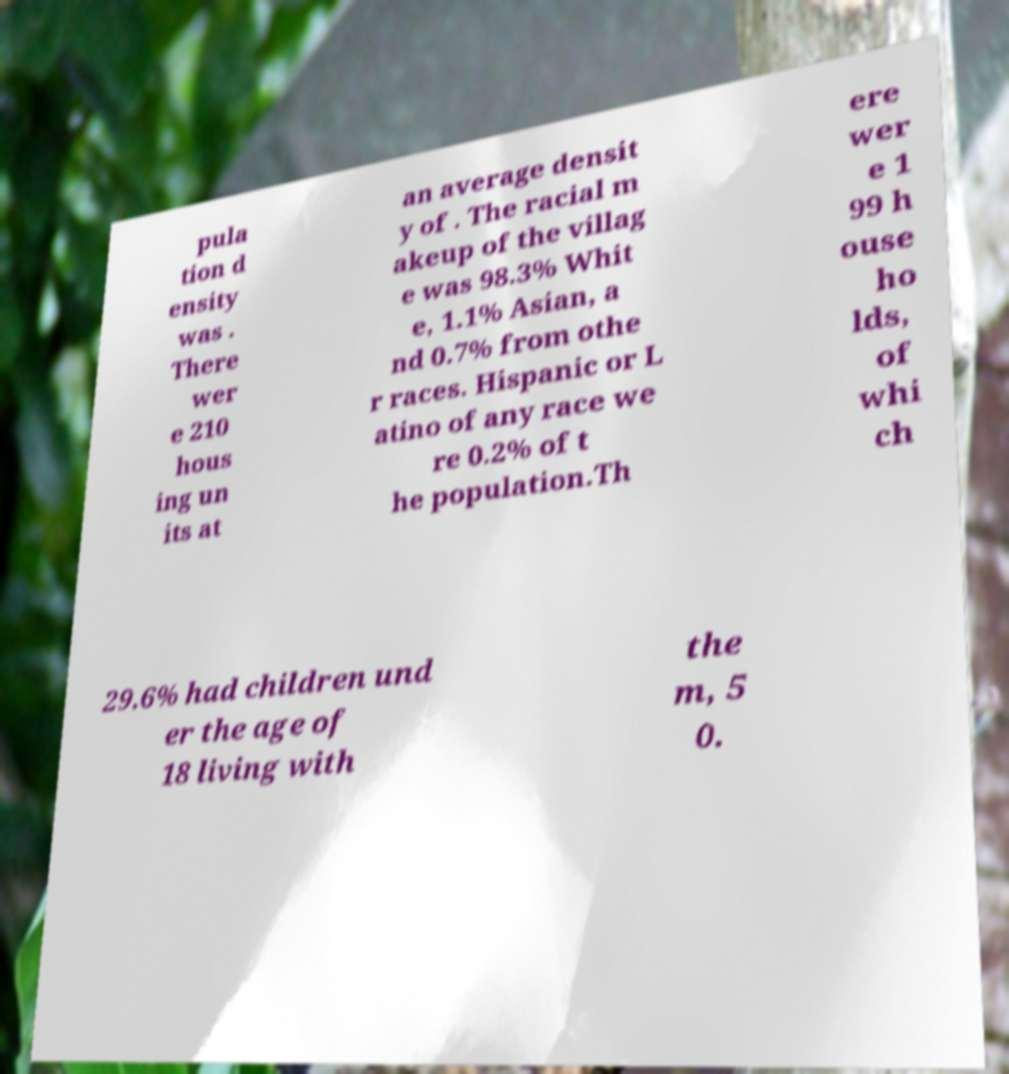Please read and relay the text visible in this image. What does it say? pula tion d ensity was . There wer e 210 hous ing un its at an average densit y of . The racial m akeup of the villag e was 98.3% Whit e, 1.1% Asian, a nd 0.7% from othe r races. Hispanic or L atino of any race we re 0.2% of t he population.Th ere wer e 1 99 h ouse ho lds, of whi ch 29.6% had children und er the age of 18 living with the m, 5 0. 